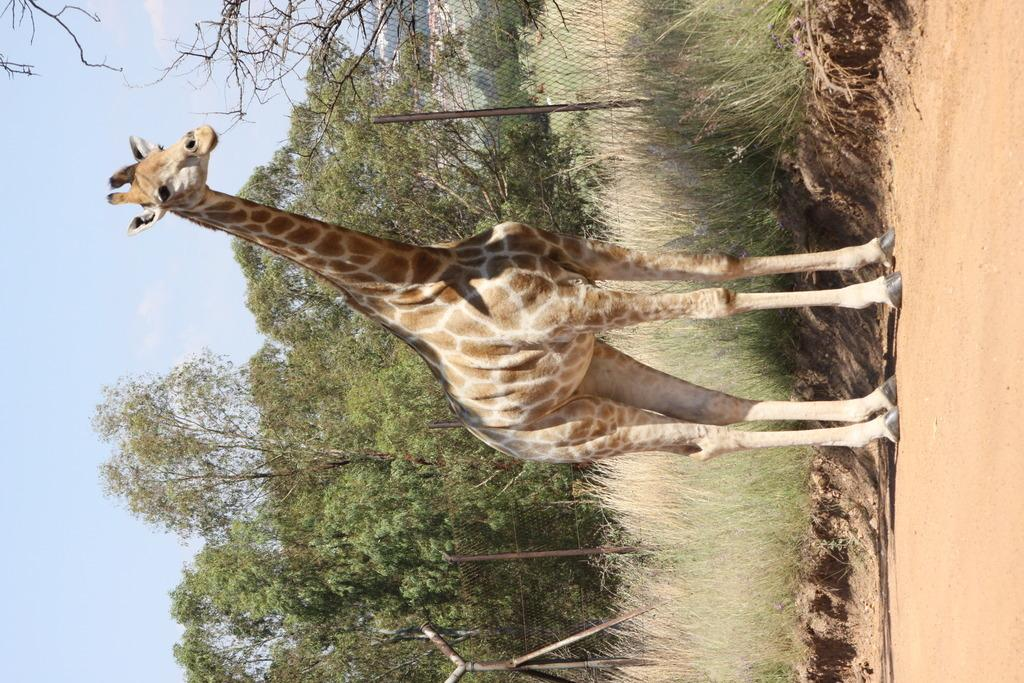What is the main subject in the center of the image? There is a giraffe in the center of the image. What can be seen in the background of the image? There are trees, a fence, and plants in the background of the image. What time does the clock show in the image? There is no clock present in the image, so it is not possible to determine the time. 